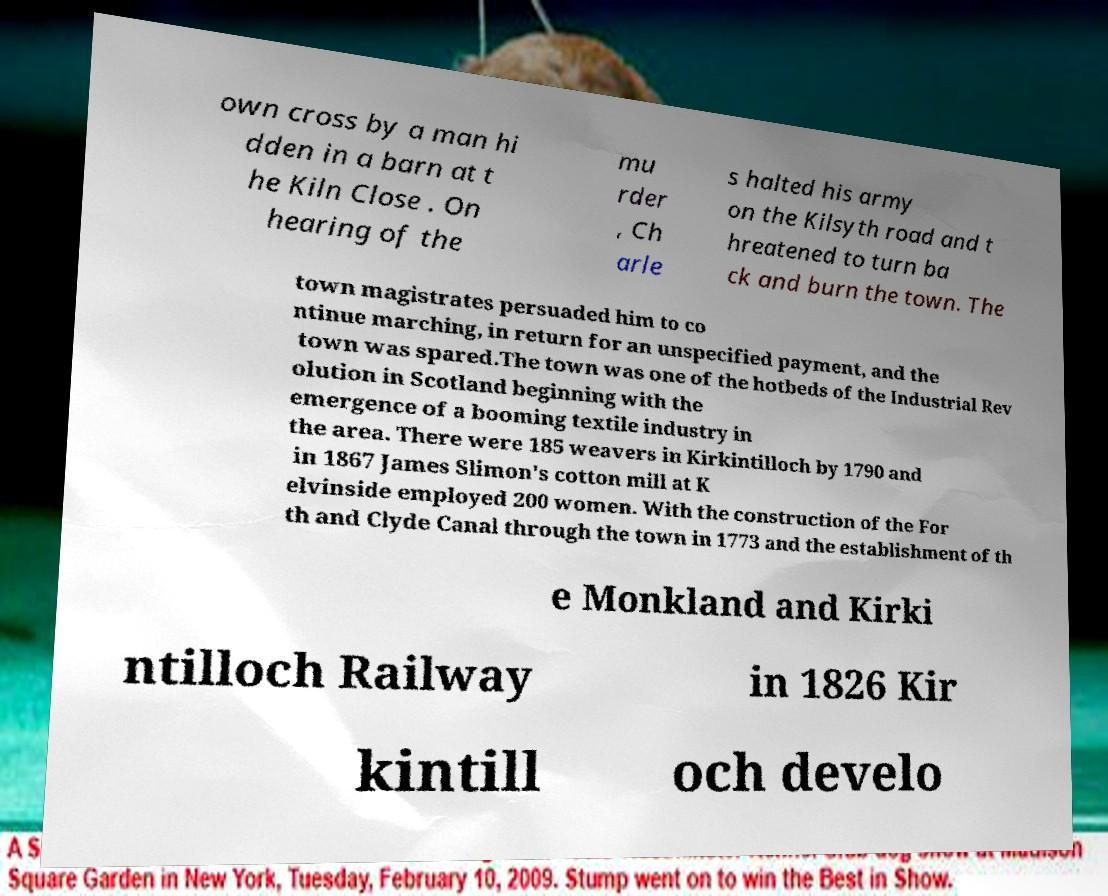Can you accurately transcribe the text from the provided image for me? own cross by a man hi dden in a barn at t he Kiln Close . On hearing of the mu rder , Ch arle s halted his army on the Kilsyth road and t hreatened to turn ba ck and burn the town. The town magistrates persuaded him to co ntinue marching, in return for an unspecified payment, and the town was spared.The town was one of the hotbeds of the Industrial Rev olution in Scotland beginning with the emergence of a booming textile industry in the area. There were 185 weavers in Kirkintilloch by 1790 and in 1867 James Slimon's cotton mill at K elvinside employed 200 women. With the construction of the For th and Clyde Canal through the town in 1773 and the establishment of th e Monkland and Kirki ntilloch Railway in 1826 Kir kintill och develo 